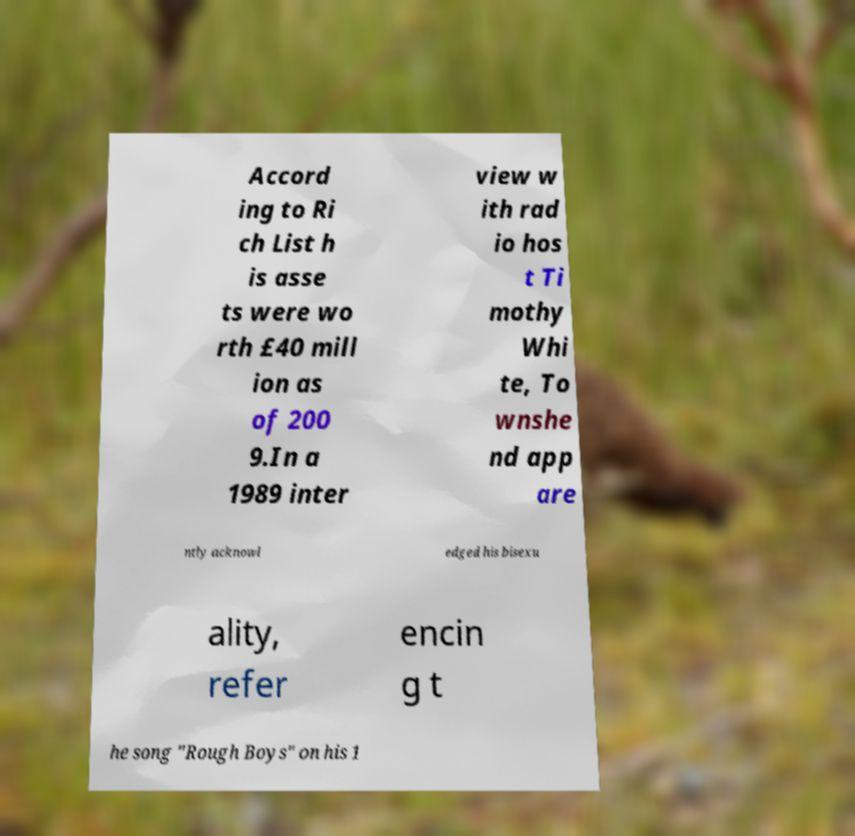Please read and relay the text visible in this image. What does it say? Accord ing to Ri ch List h is asse ts were wo rth £40 mill ion as of 200 9.In a 1989 inter view w ith rad io hos t Ti mothy Whi te, To wnshe nd app are ntly acknowl edged his bisexu ality, refer encin g t he song "Rough Boys" on his 1 